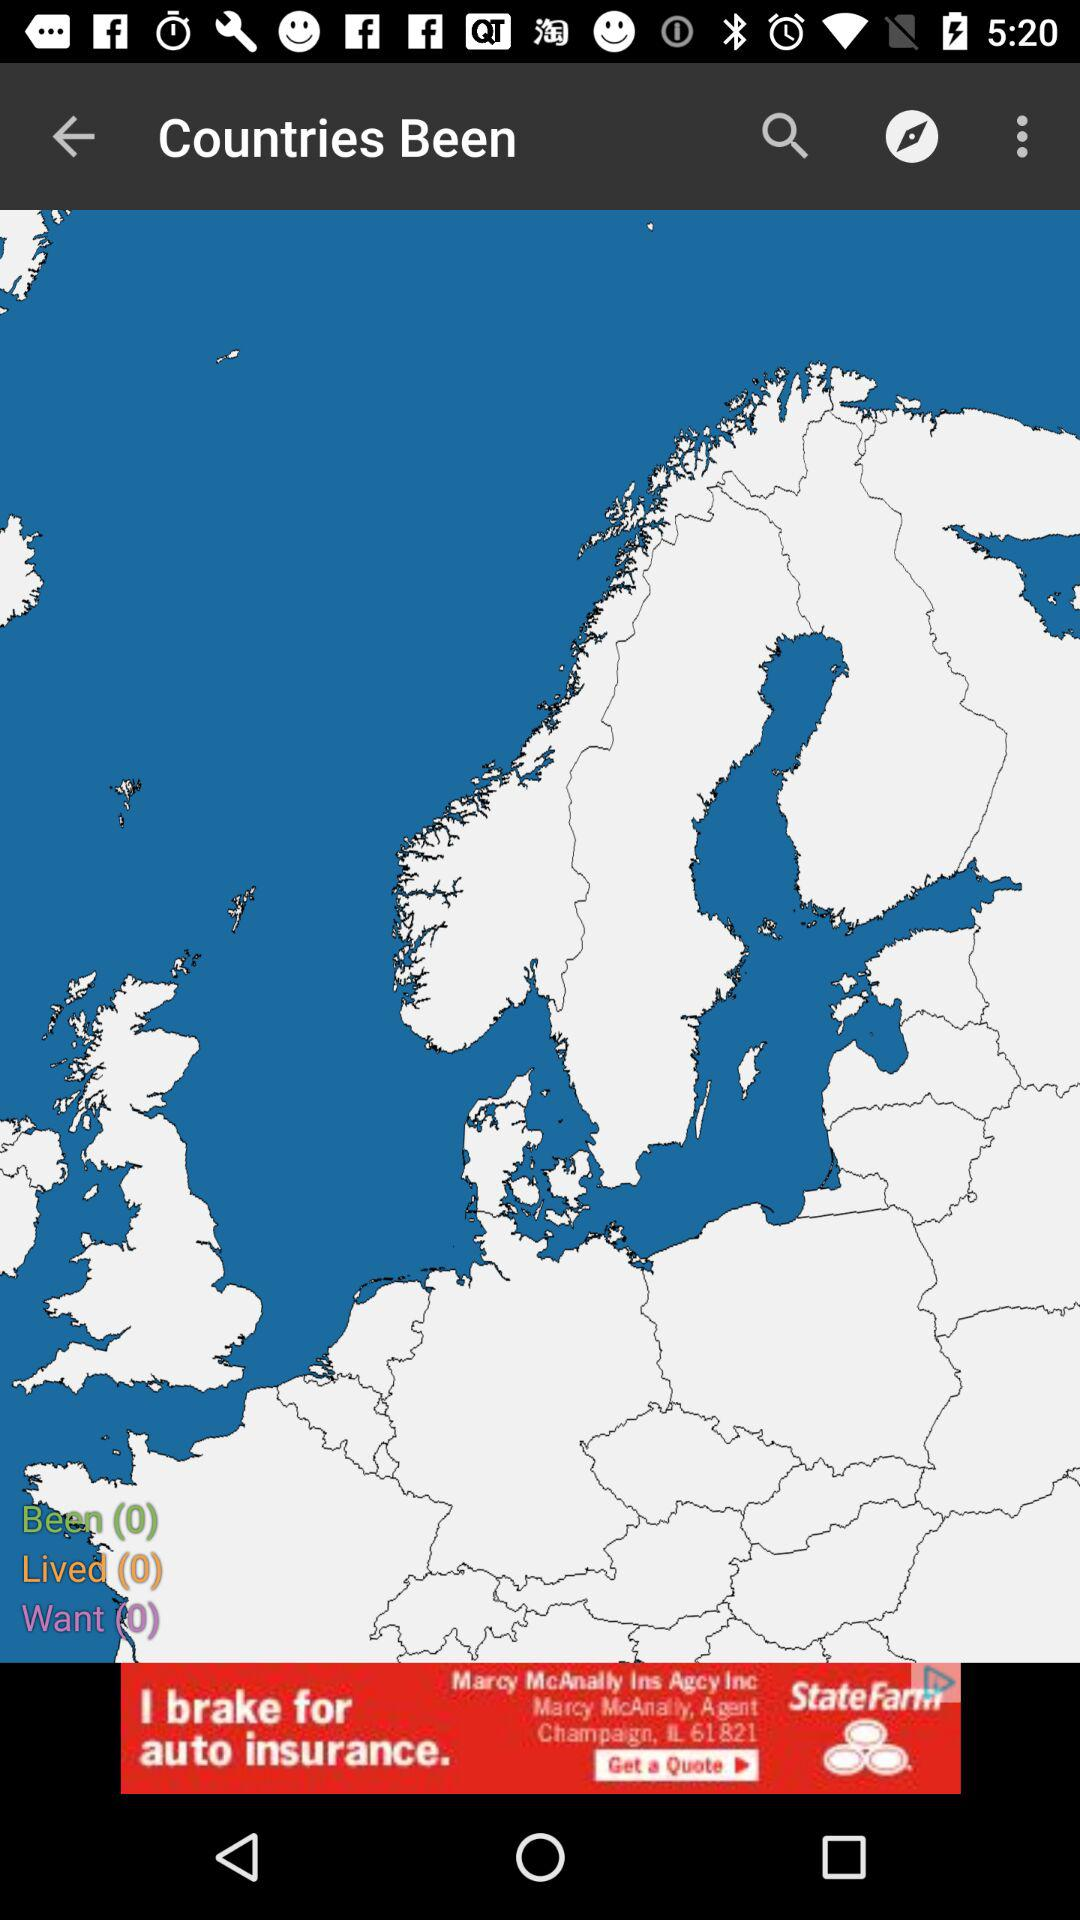How many countries do I want to visit? You want to visit 0 countries. 